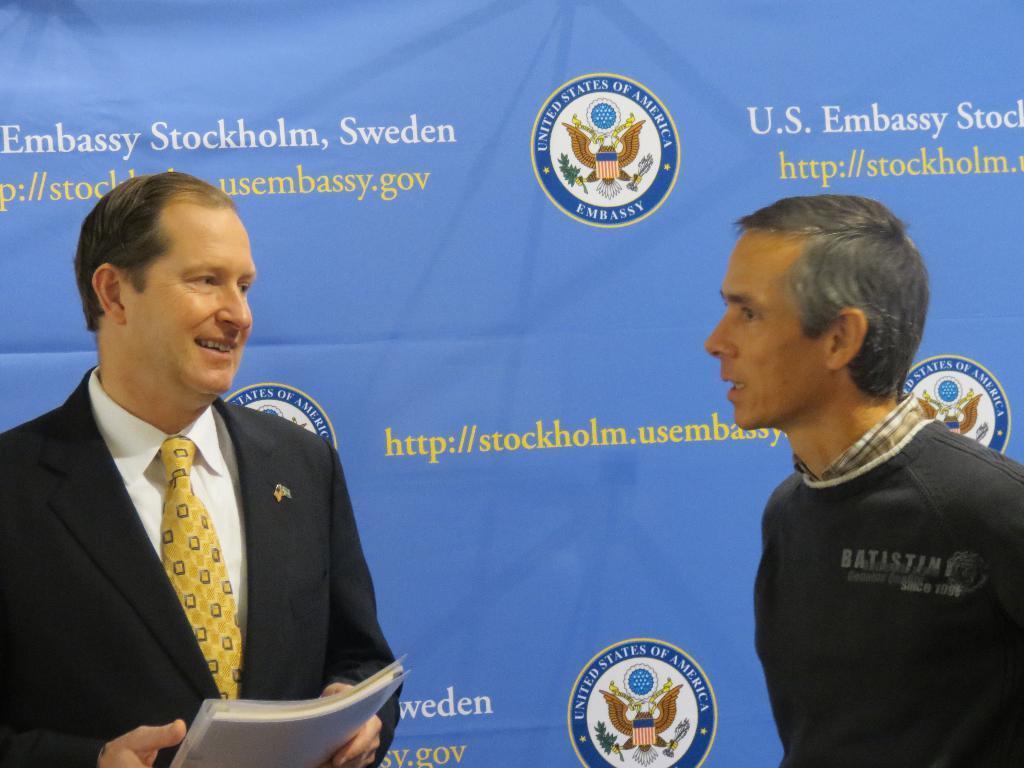How would you summarize this image in a sentence or two? In the foreground of this image, there are two men standing where a man is holding a book. In the background, there is a banner. 